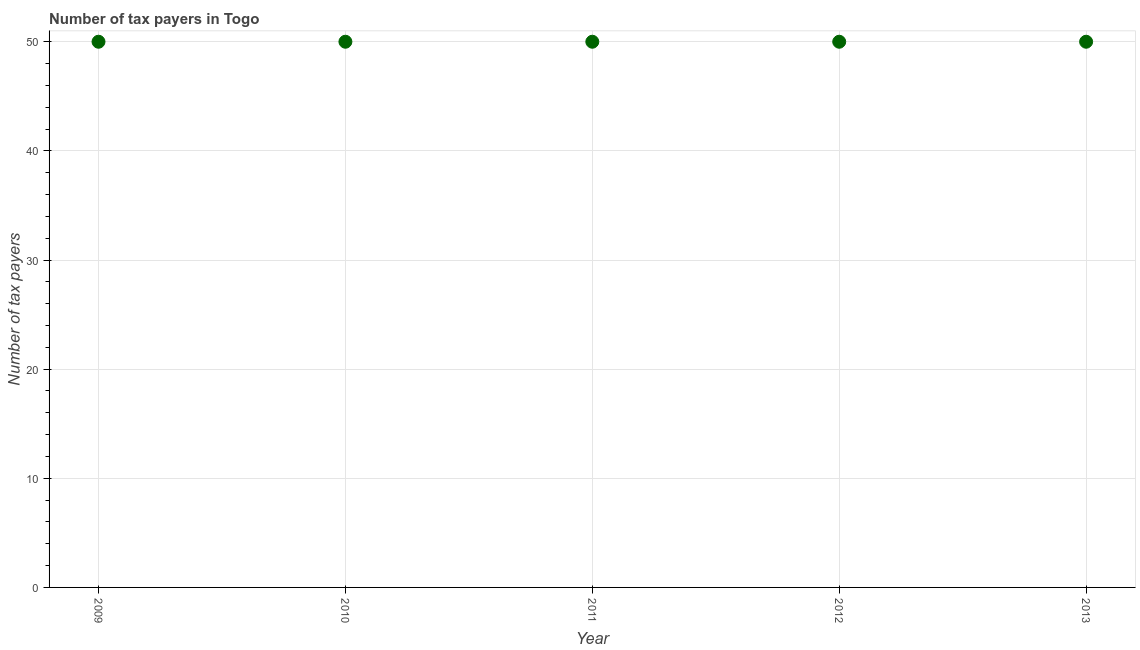What is the number of tax payers in 2012?
Make the answer very short. 50. Across all years, what is the maximum number of tax payers?
Your answer should be very brief. 50. Across all years, what is the minimum number of tax payers?
Your answer should be compact. 50. In which year was the number of tax payers maximum?
Keep it short and to the point. 2009. In which year was the number of tax payers minimum?
Your answer should be very brief. 2009. What is the sum of the number of tax payers?
Your answer should be compact. 250. What is the average number of tax payers per year?
Your answer should be very brief. 50. What is the median number of tax payers?
Your response must be concise. 50. Is the number of tax payers in 2012 less than that in 2013?
Your response must be concise. No. Is the difference between the number of tax payers in 2012 and 2013 greater than the difference between any two years?
Ensure brevity in your answer.  Yes. Is the sum of the number of tax payers in 2009 and 2013 greater than the maximum number of tax payers across all years?
Offer a very short reply. Yes. What is the difference between the highest and the lowest number of tax payers?
Provide a succinct answer. 0. How many dotlines are there?
Your answer should be very brief. 1. Are the values on the major ticks of Y-axis written in scientific E-notation?
Provide a short and direct response. No. Does the graph contain any zero values?
Provide a succinct answer. No. Does the graph contain grids?
Make the answer very short. Yes. What is the title of the graph?
Ensure brevity in your answer.  Number of tax payers in Togo. What is the label or title of the X-axis?
Your answer should be very brief. Year. What is the label or title of the Y-axis?
Provide a short and direct response. Number of tax payers. What is the Number of tax payers in 2010?
Your answer should be compact. 50. What is the difference between the Number of tax payers in 2009 and 2010?
Give a very brief answer. 0. What is the difference between the Number of tax payers in 2009 and 2011?
Your answer should be compact. 0. What is the difference between the Number of tax payers in 2009 and 2013?
Give a very brief answer. 0. What is the difference between the Number of tax payers in 2011 and 2012?
Make the answer very short. 0. What is the difference between the Number of tax payers in 2012 and 2013?
Offer a very short reply. 0. What is the ratio of the Number of tax payers in 2009 to that in 2010?
Keep it short and to the point. 1. What is the ratio of the Number of tax payers in 2009 to that in 2011?
Offer a terse response. 1. What is the ratio of the Number of tax payers in 2009 to that in 2013?
Give a very brief answer. 1. What is the ratio of the Number of tax payers in 2010 to that in 2011?
Provide a short and direct response. 1. What is the ratio of the Number of tax payers in 2010 to that in 2013?
Offer a very short reply. 1. What is the ratio of the Number of tax payers in 2011 to that in 2012?
Keep it short and to the point. 1. 